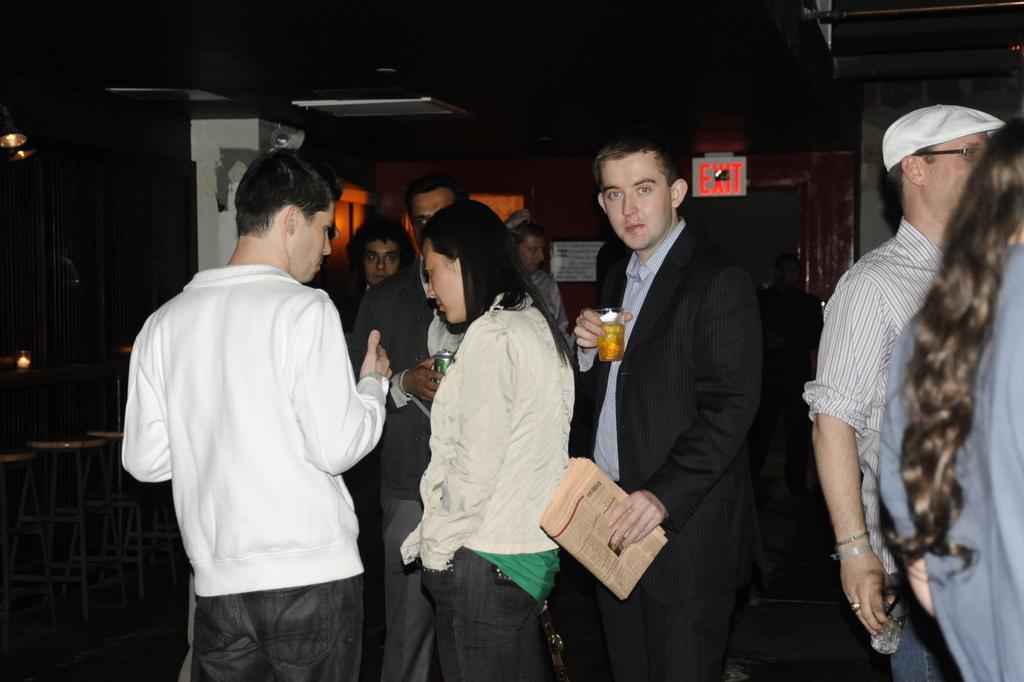Describe this image in one or two sentences. Here on the right side of the picture we can see a old man wearing a cap and spectacles with glass in his hand. Beside him there is a young man with newspaper in his hand and a drink in another hand. And at the left side of the picture we can see 3 people talking to each other and at the corner of the picture we see a man who is listening to these 3 people. 